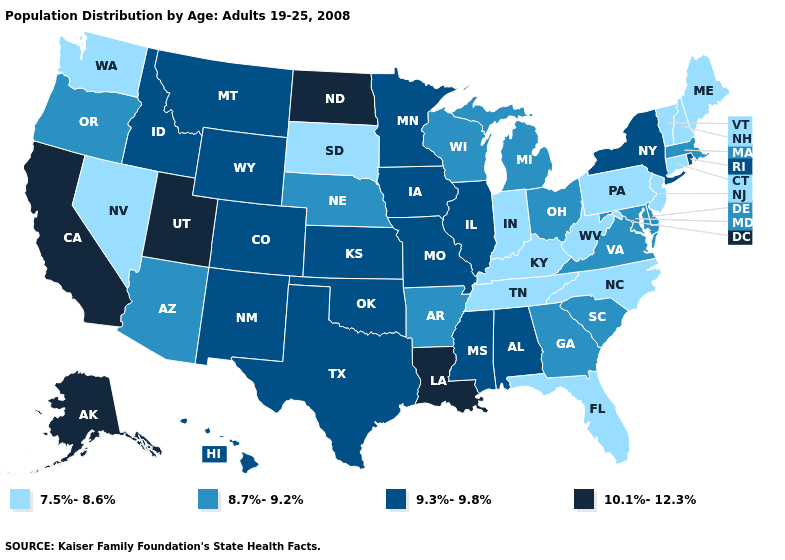Name the states that have a value in the range 8.7%-9.2%?
Answer briefly. Arizona, Arkansas, Delaware, Georgia, Maryland, Massachusetts, Michigan, Nebraska, Ohio, Oregon, South Carolina, Virginia, Wisconsin. What is the value of Iowa?
Keep it brief. 9.3%-9.8%. What is the value of Georgia?
Concise answer only. 8.7%-9.2%. What is the value of Maryland?
Answer briefly. 8.7%-9.2%. Is the legend a continuous bar?
Keep it brief. No. What is the lowest value in the South?
Concise answer only. 7.5%-8.6%. Is the legend a continuous bar?
Quick response, please. No. Name the states that have a value in the range 8.7%-9.2%?
Quick response, please. Arizona, Arkansas, Delaware, Georgia, Maryland, Massachusetts, Michigan, Nebraska, Ohio, Oregon, South Carolina, Virginia, Wisconsin. Does Nebraska have a lower value than South Dakota?
Concise answer only. No. Does the first symbol in the legend represent the smallest category?
Quick response, please. Yes. Does Utah have the highest value in the USA?
Give a very brief answer. Yes. What is the value of South Dakota?
Keep it brief. 7.5%-8.6%. Which states have the lowest value in the USA?
Keep it brief. Connecticut, Florida, Indiana, Kentucky, Maine, Nevada, New Hampshire, New Jersey, North Carolina, Pennsylvania, South Dakota, Tennessee, Vermont, Washington, West Virginia. Name the states that have a value in the range 9.3%-9.8%?
Write a very short answer. Alabama, Colorado, Hawaii, Idaho, Illinois, Iowa, Kansas, Minnesota, Mississippi, Missouri, Montana, New Mexico, New York, Oklahoma, Rhode Island, Texas, Wyoming. What is the value of New Hampshire?
Concise answer only. 7.5%-8.6%. 